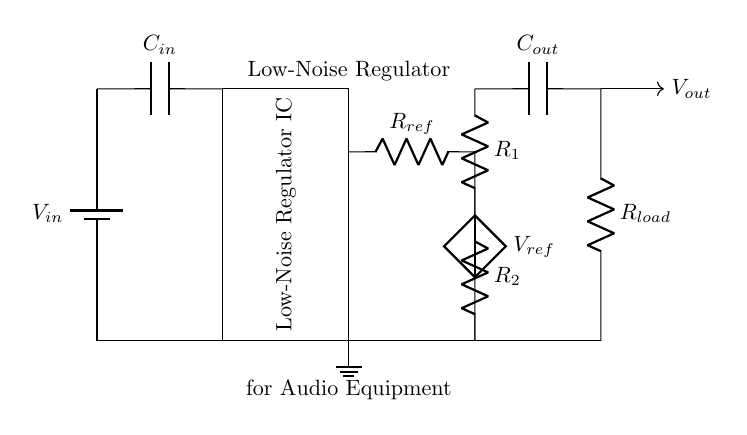what is the input voltage of the circuit? The input voltage is represented by the symbol \( V_{in} \) connected to the battery, which indicates a direct voltage source.
Answer: \( V_{in} \) what does the \( C_{in} \) capacitor do? The capacitor \( C_{in} \) is placed in series with the input voltage and serves to filter out noise and ripple from the incoming power supply, providing a smoother voltage to the regulator.
Answer: filter noise what are the resistors \( R_1 \) and \( R_2 \) used for? Resistors \( R_1 \) and \( R_2 \) form a feedback network that sets the output voltage by providing the necessary reference voltage to the low-noise regulator.
Answer: set output voltage how many capacitors are in the circuit? There are two capacitors in the circuit: \( C_{in} \) for input and \( C_{out} \) for output, both essential for smoothing the voltage signals.
Answer: two what is the purpose of the load resistor \( R_{load} \)? The load resistor \( R_{load} \) connects to the output of the regulator, representing the actual load that the regulator will supply power to, allowing evaluation of the regulator's performance under load conditions.
Answer: supply power what is the function of the low-noise regulator IC? The low-noise regulator IC regulates the output voltage to a stable level while minimizing noise, crucial for maintaining audio quality in installations sensitive to power fluctuations.
Answer: regulate voltage what is the reference voltage labeled as \( V_{ref} \)? \( V_{ref} \) indicates the reference voltage level against which the output voltage is compared in the feedback loop to maintain a consistent output as dictated by the configured resistors.
Answer: reference voltage 